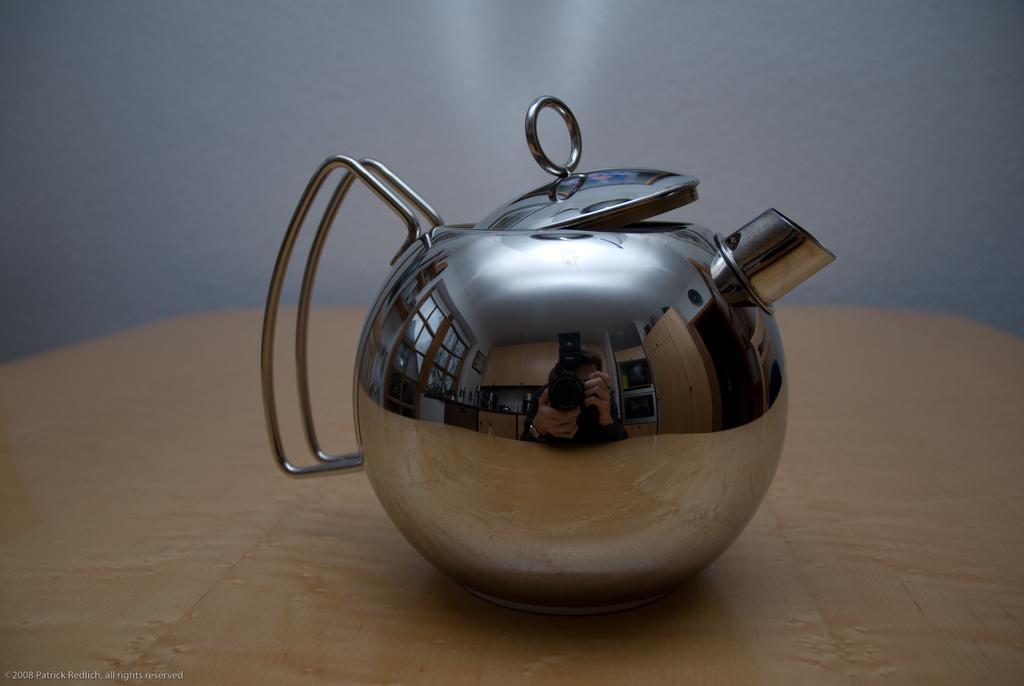Please provide a concise description of this image. Int this image there is a kettle in the center which is on the wooden table. 